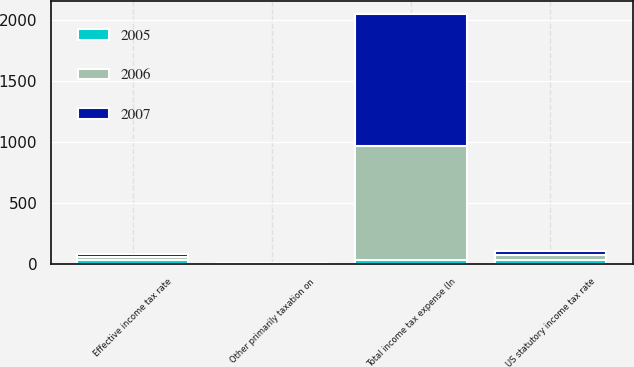Convert chart to OTSL. <chart><loc_0><loc_0><loc_500><loc_500><stacked_bar_chart><ecel><fcel>Total income tax expense (In<fcel>US statutory income tax rate<fcel>Other primarily taxation on<fcel>Effective income tax rate<nl><fcel>2007<fcel>1078<fcel>35<fcel>3<fcel>26<nl><fcel>2006<fcel>936<fcel>35<fcel>3<fcel>26<nl><fcel>2005<fcel>34<fcel>35<fcel>2<fcel>34<nl></chart> 